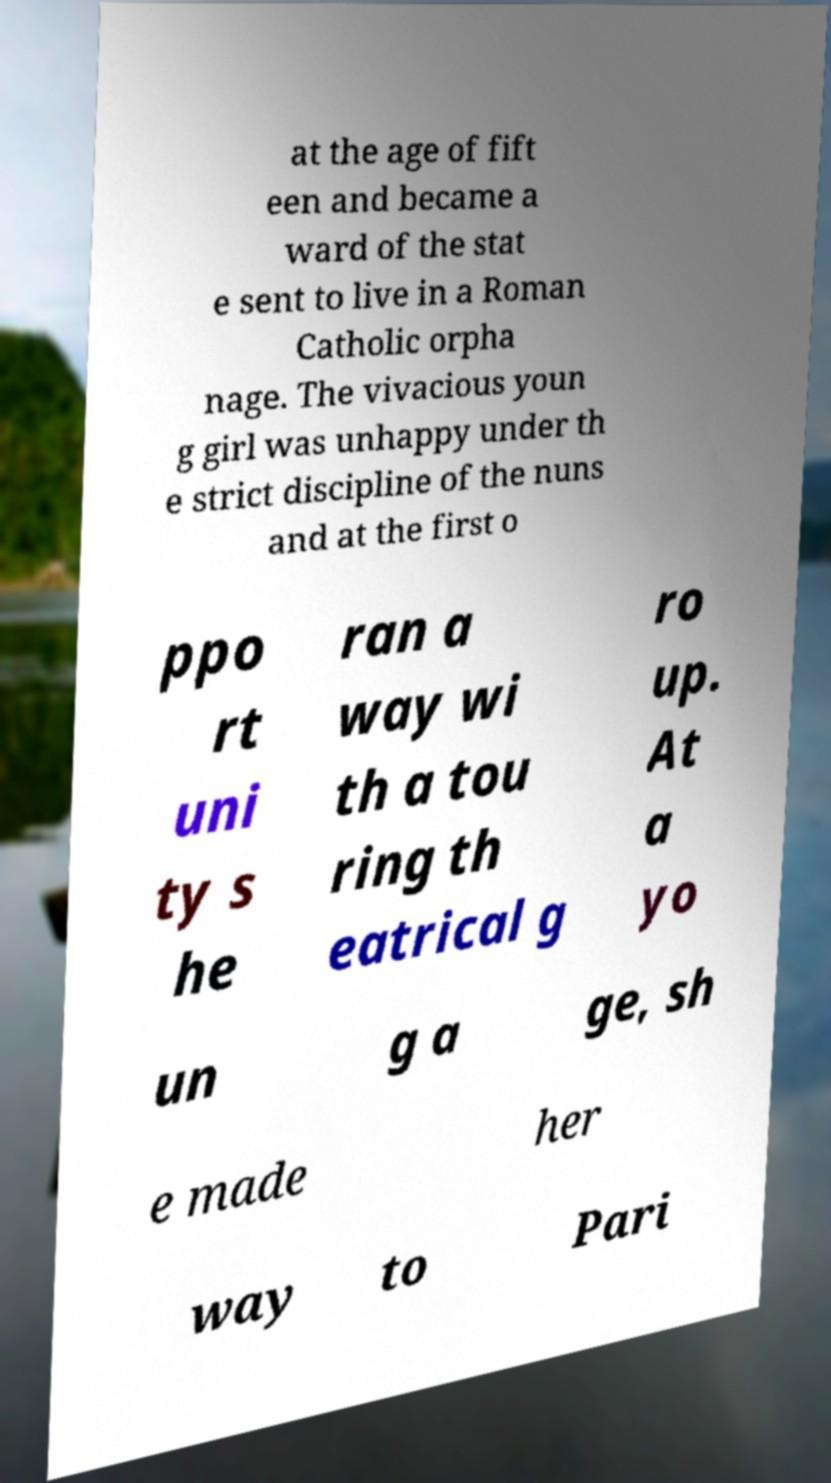There's text embedded in this image that I need extracted. Can you transcribe it verbatim? at the age of fift een and became a ward of the stat e sent to live in a Roman Catholic orpha nage. The vivacious youn g girl was unhappy under th e strict discipline of the nuns and at the first o ppo rt uni ty s he ran a way wi th a tou ring th eatrical g ro up. At a yo un g a ge, sh e made her way to Pari 